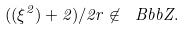Convert formula to latex. <formula><loc_0><loc_0><loc_500><loc_500>( ( \xi ^ { 2 } ) + 2 ) / 2 r \not \in { \ B b b Z } .</formula> 